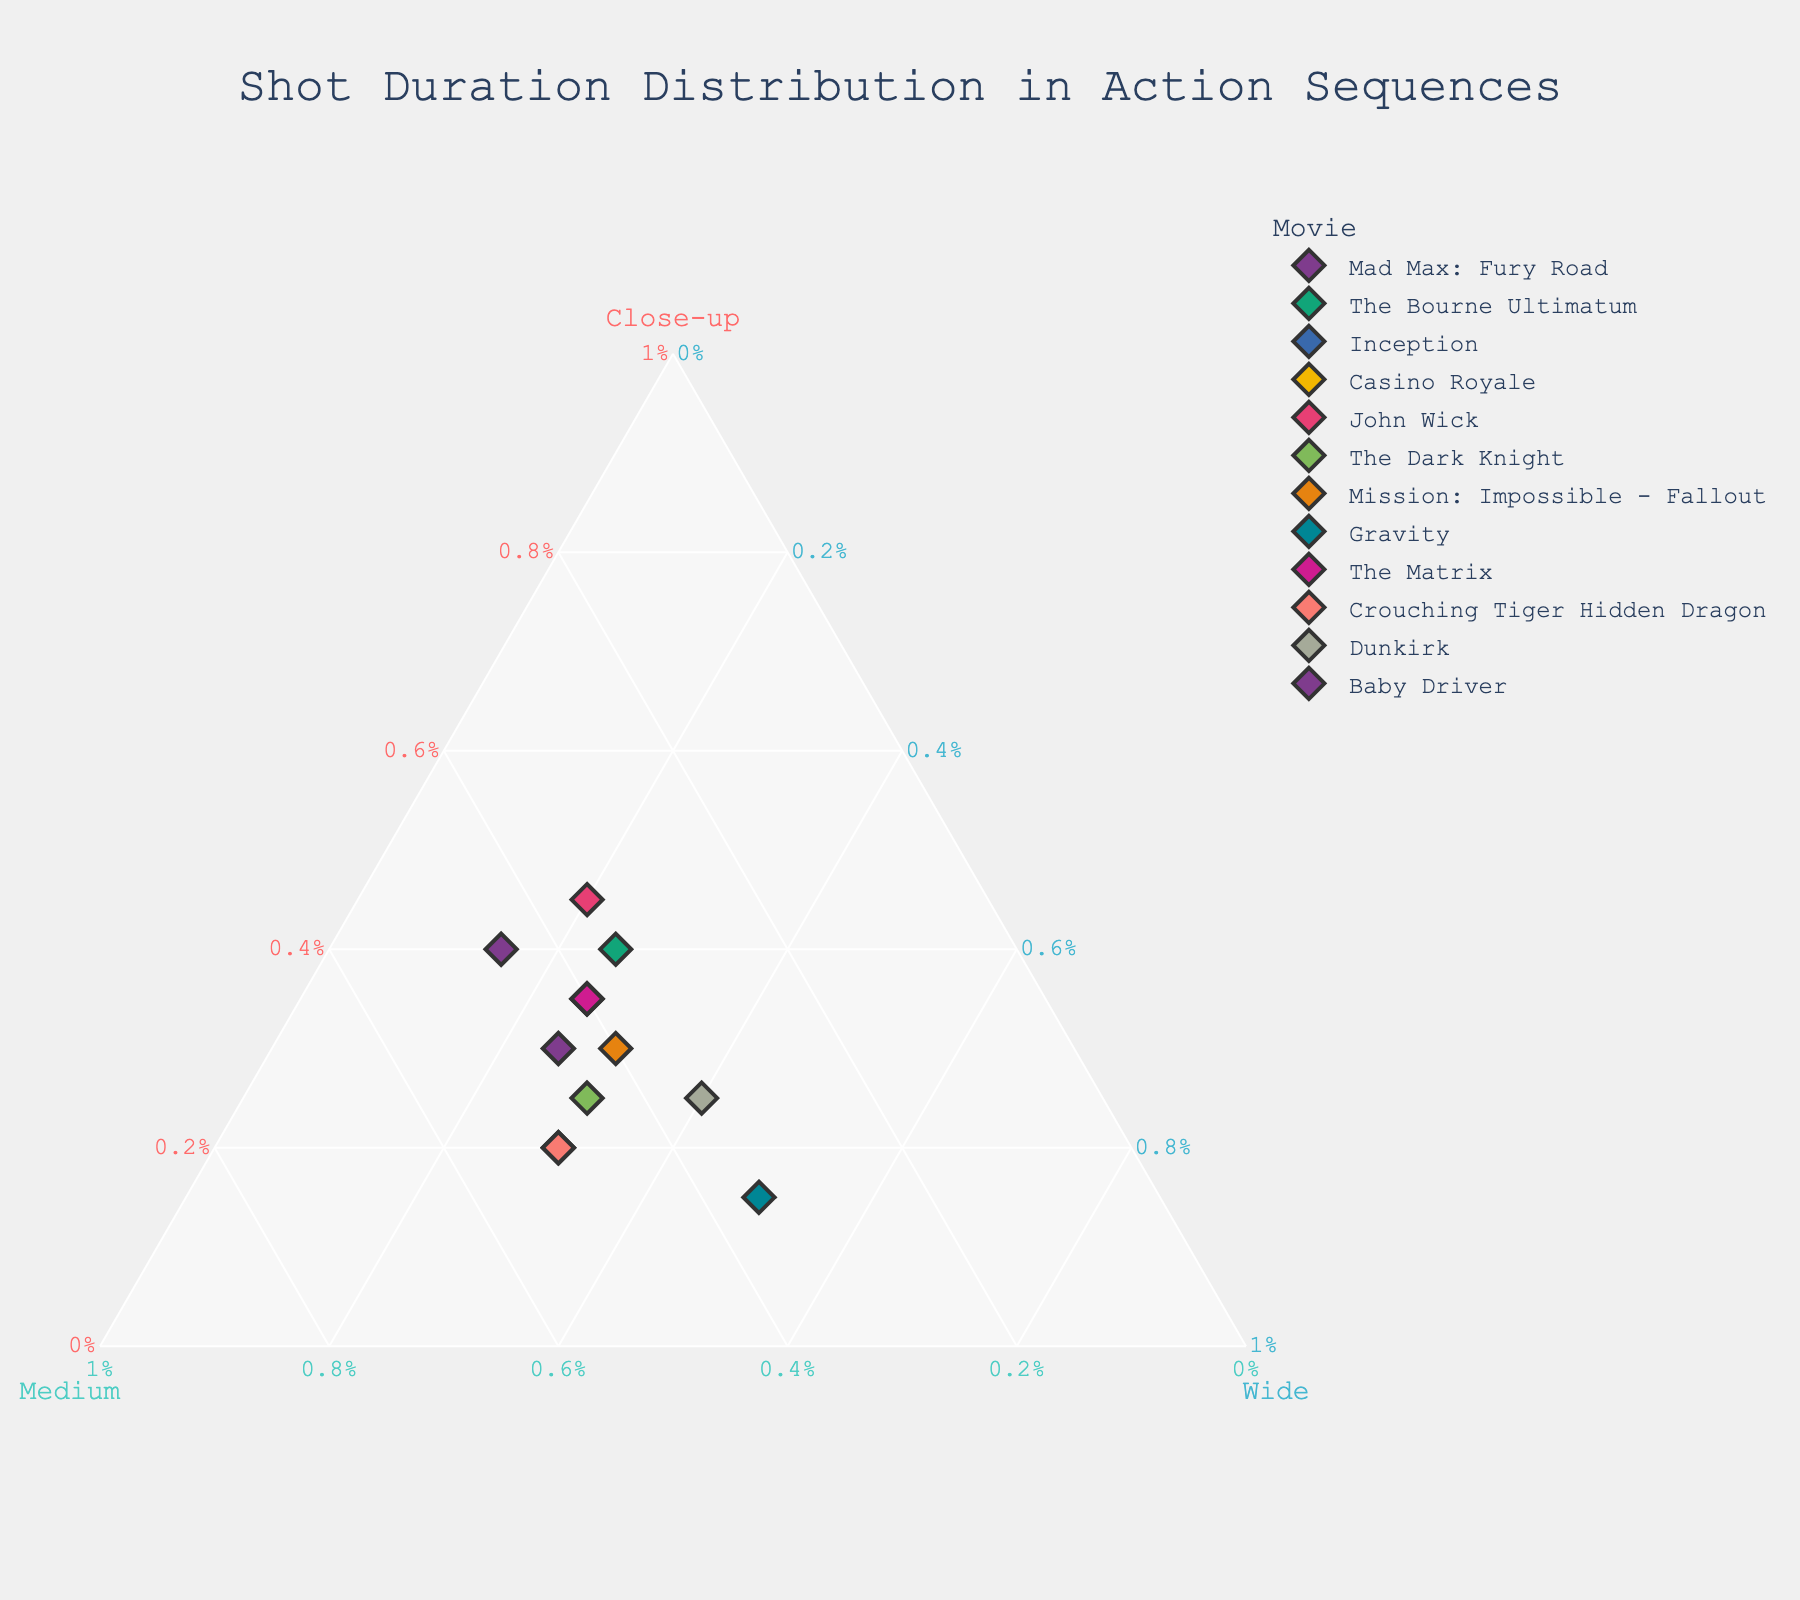Which movie has the highest percentage of close-up shots? By examining the plot, the movie located furthest towards the "Close-up" axis indicates the highest percentage of close-up shots. "John Wick" is closest to this axis.
Answer: John Wick What is the title of the plot? The title is usually prominently displayed at the top center of the plot. It reads "Shot Duration Distribution in Action Sequences."
Answer: Shot Duration Distribution in Action Sequences Which two movies have a higher proportion of wide shots compared to close-up shots? By identifying points closer to the "Wide" axis than to the "Close-up" axis, "Gravity" and "Dunkirk" fit this criterion.
Answer: Gravity and Dunkirk How does the close-up shot distribution in "Baby Driver" compare to "The Bourne Ultimatum"? "Baby Driver" is closer to the "Close-up" axis than "The Bourne Ultimatum," indicating a higher percentage of close-up shots.
Answer: Baby Driver has a higher percentage of close-up shots What movie is represented by the point closest to the center of the ternary plot? The center represents a balance between close-up, medium, and wide shots. "Mission: Impossible - Fallout" is nearest to the center.
Answer: Mission: Impossible - Fallout Which movie has the smallest proportion of wide shots? By finding the point closest to the "Close-up" and "Medium" axes, "Baby Driver" indicates the smallest proportion of wide shots.
Answer: Baby Driver How is "Crouching Tiger Hidden Dragon" represented in terms of medium and wide shots? "Crouching Tiger Hidden Dragon" is closest to the "Medium" axis compared to the "Wide" axis, implying a higher proportion of medium shots over wide shots.
Answer: Higher proportion of medium shots Between "The Matrix" and "Casino Royale," which one has a higher percentage of medium shots? By locating both points and identifying the one closer to the "Medium" axis, "Casino Royale" has a higher percentage of medium shots compared to "The Matrix".
Answer: Casino Royale Which movie has a similar distribution of shot types as "John Wick"? A similar distribution means points are closer together. "The Bourne Ultimatum" is closest to "John Wick" on the plot.
Answer: The Bourne Ultimatum 